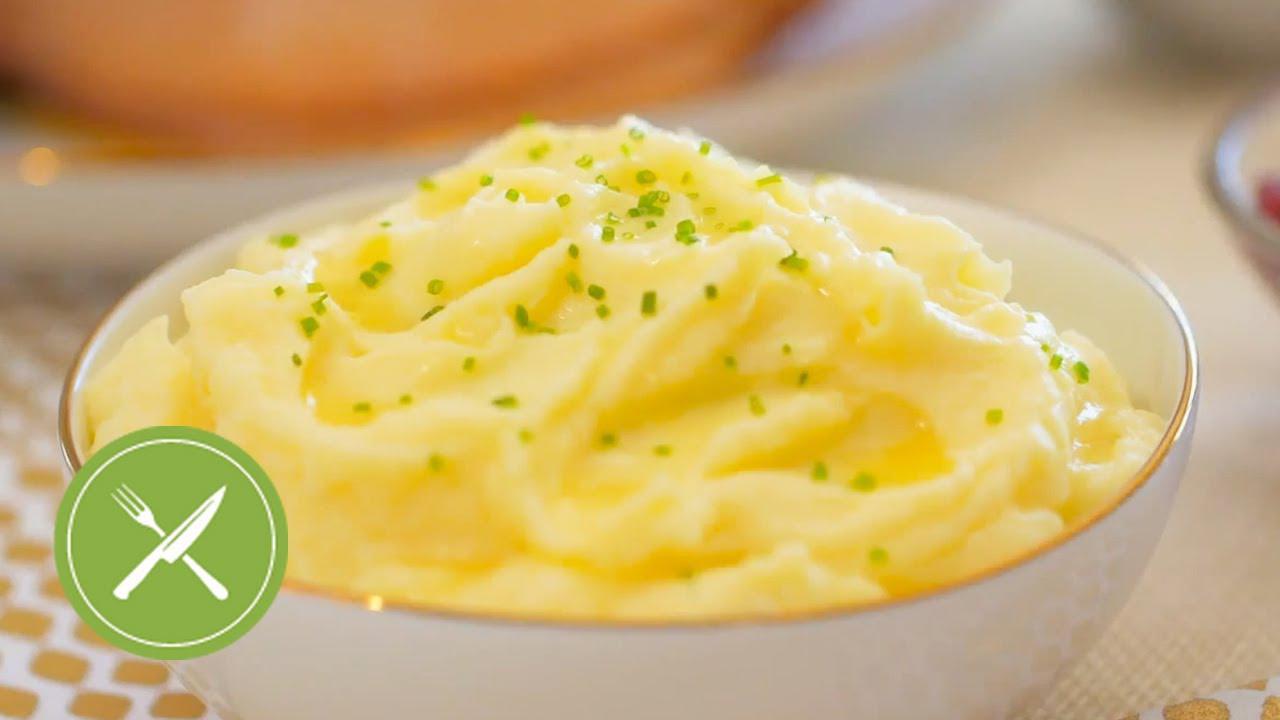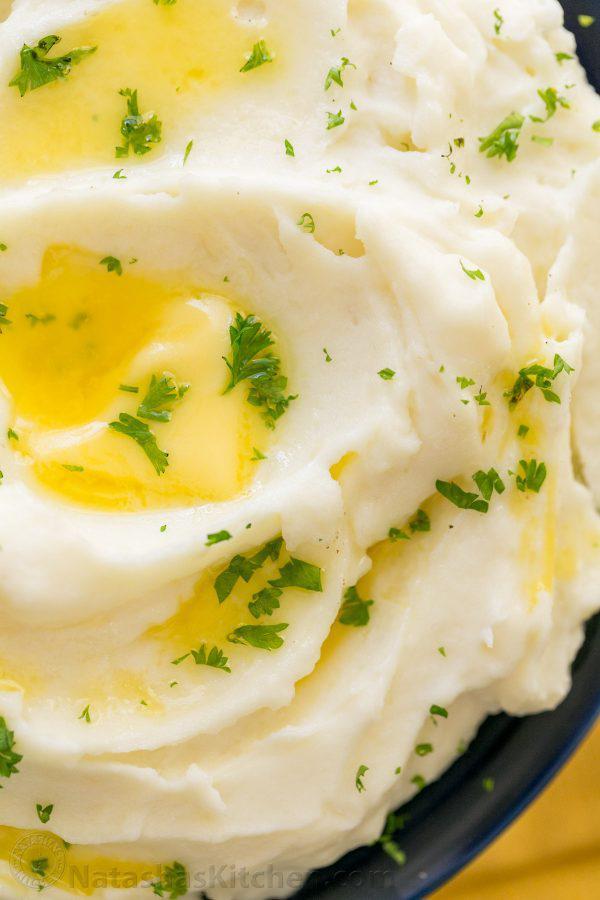The first image is the image on the left, the second image is the image on the right. Considering the images on both sides, is "An image shows a bowl of potatoes with handle of a utensil sticking out." valid? Answer yes or no. No. The first image is the image on the left, the second image is the image on the right. Evaluate the accuracy of this statement regarding the images: "A vegetable is visible in one of the images.". Is it true? Answer yes or no. No. 